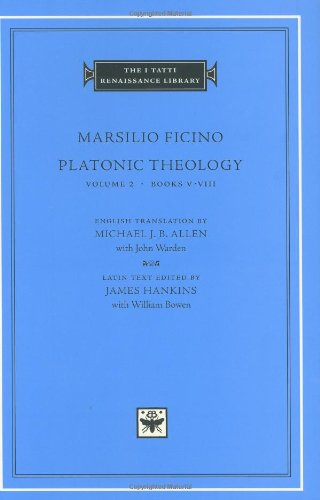Is this book related to Politics & Social Sciences? Yes, 'Platonic Theology' intersects with the field of Politics & Social Sciences through its deep exploration of philosophical ideas that have significantly shaped Western intellectual history and social thought. 